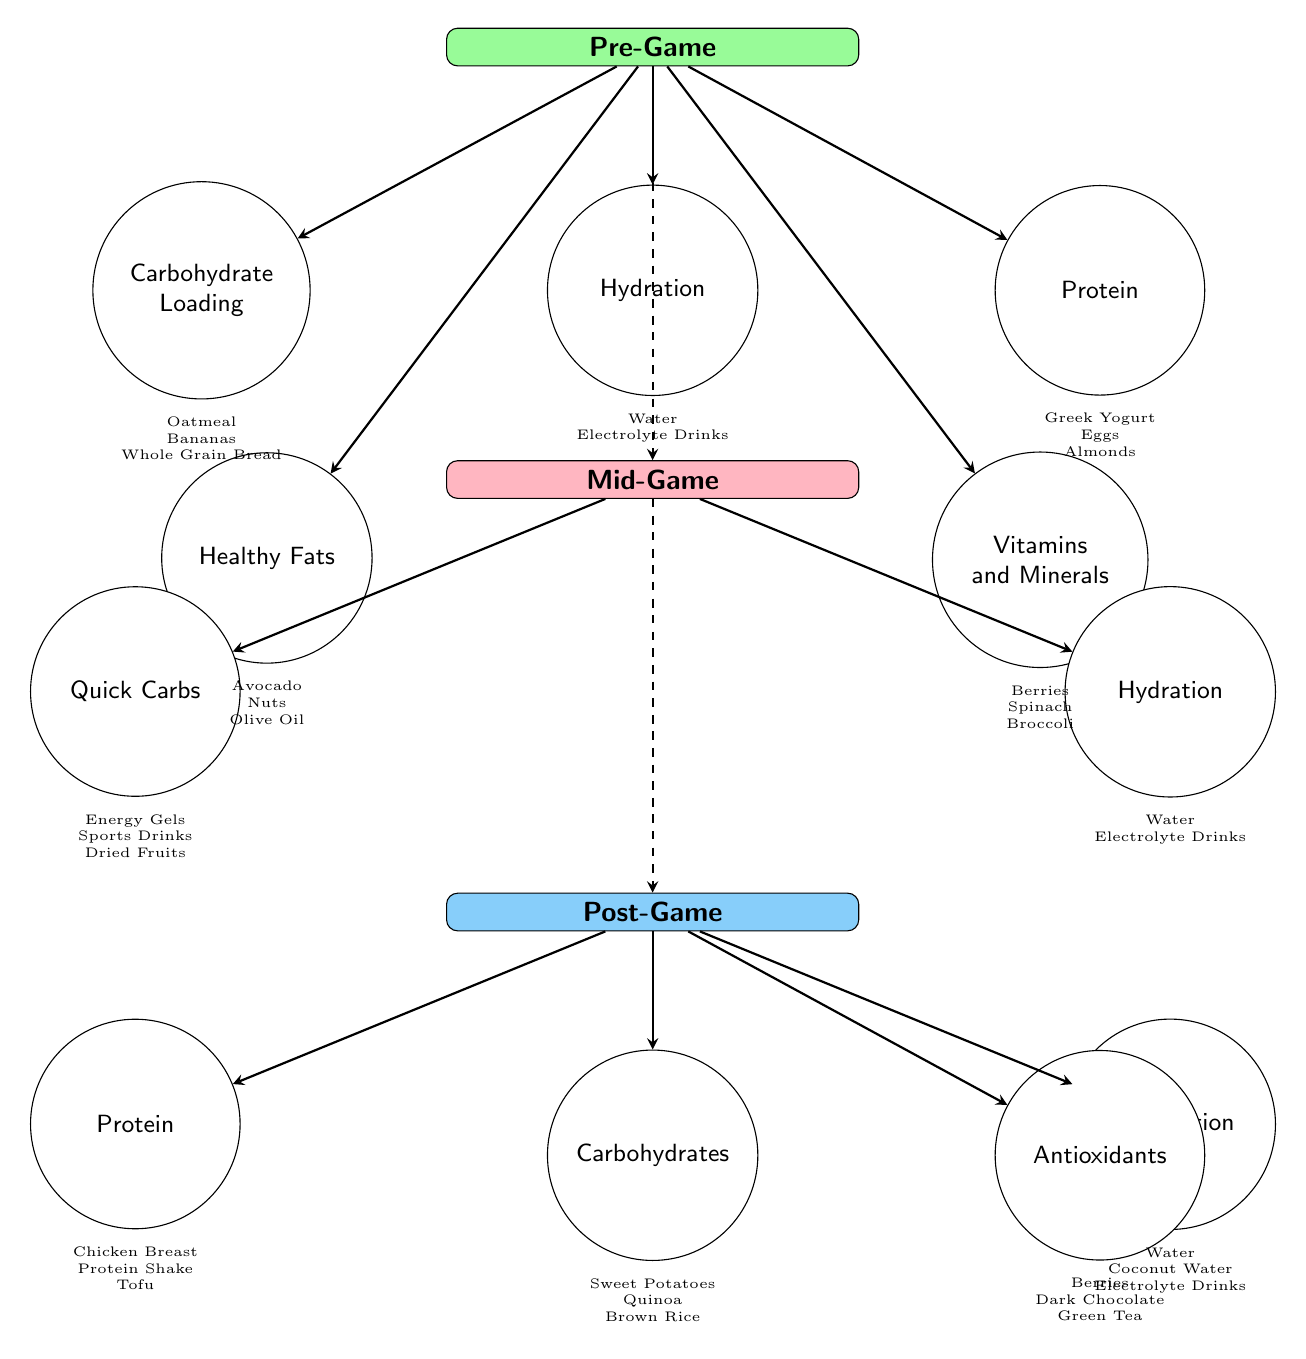What are the two main stages of nutrition before the game starts? The diagram shows two main stages before the game begins: "Pre-Game" and "Mid-Game". These stages are visually represented, and "Mid-Game" is the next step after "Pre-Game".
Answer: Pre-Game, Mid-Game How many food items are listed under "Post-Game"? Looking at the "Post-Game" section of the diagram, there are four items directly connected to this stage: "Protein," "Carbohydrates," "Rehydration," and "Antioxidants." Counting them gives a total of four items.
Answer: 4 Which carbohydrate sources are recommended for the Pre-Game phase? In the Pre-Game section, the carbohydrate sources are detailed as "Oatmeal, Bananas, Whole Grain Bread". Therefore, these are recommended for carbohydrate loading before the game.
Answer: Oatmeal, Bananas, Whole Grain Bread What type of hydration is suggested during the Mid-Game? The Mid-Game section indicates "Hydration" as one of the items, and under it, the specific sources are listed as "Water, Electrolyte Drinks". These types are suggested for hydration during the Mid-Game.
Answer: Water, Electrolyte Drinks Which food item is linked to both the Pre-Game and Post-Game stages? The diagram outlines connections and food items in each stage. In reviewing connections, "Protein" appears in both the Pre-Game (as a food source) and the Post-Game (as a recovery source) stages. This indicates its relevance in both contexts.
Answer: Protein How does the flow of nutrition change from Pre-Game to Mid-Game? The diagram indicates that the nutrition flow transitions from "Pre-Game" to "Mid-Game" via a dashed arrow, which suggests a continuation of nutritional strategy but does not explicitly show food items transitioning. It emphasizes that preparation leads directly into game needs.
Answer: Continues through dashed arrows Which vitamin sources are recommended in the Pre-Game stage? The Pre-Game nutrition section specifies "Berries, Spinach, Broccoli" as the sources of vitamins and minerals. These sources are essential for overall preparation before competition.
Answer: Berries, Spinach, Broccoli What is the purpose of quick carbs in the Mid-Game phase? Quick carbs, such as those listed as "Energy Gels, Sports Drinks, Dried Fruits" under the Mid-Game stage, provide immediate energy to sustain performance during the competition, indicating their importance for maintaining energy levels.
Answer: Immediate energy What are the sources of antioxidants mentioned in the Post-Game recovery? In the Post-Game section, antioxidants are specifically listed as "Berries, Dark Chocolate, Green Tea." These items are aimed at aiding recovery and reducing oxidative stress after the competition.
Answer: Berries, Dark Chocolate, Green Tea 